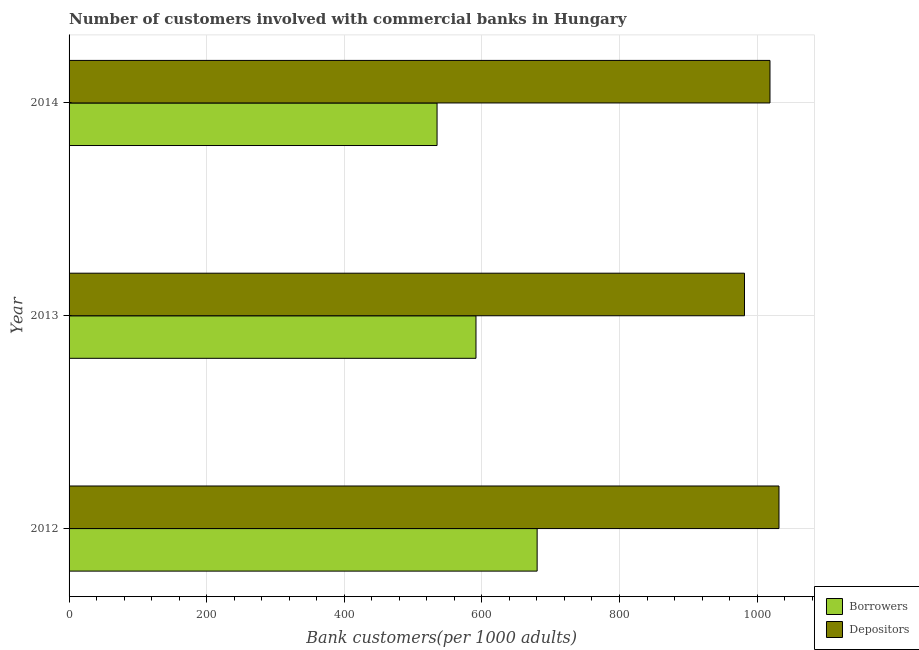How many different coloured bars are there?
Give a very brief answer. 2. How many groups of bars are there?
Your answer should be compact. 3. What is the label of the 3rd group of bars from the top?
Ensure brevity in your answer.  2012. What is the number of depositors in 2014?
Offer a terse response. 1018.74. Across all years, what is the maximum number of depositors?
Your answer should be very brief. 1031.82. Across all years, what is the minimum number of borrowers?
Make the answer very short. 534.85. What is the total number of borrowers in the graph?
Keep it short and to the point. 1806.59. What is the difference between the number of depositors in 2013 and that in 2014?
Ensure brevity in your answer.  -37.08. What is the difference between the number of borrowers in 2012 and the number of depositors in 2014?
Your answer should be very brief. -338.42. What is the average number of borrowers per year?
Your answer should be very brief. 602.2. In the year 2013, what is the difference between the number of borrowers and number of depositors?
Your answer should be compact. -390.25. What is the ratio of the number of borrowers in 2013 to that in 2014?
Your response must be concise. 1.11. Is the difference between the number of depositors in 2013 and 2014 greater than the difference between the number of borrowers in 2013 and 2014?
Your response must be concise. No. What is the difference between the highest and the second highest number of depositors?
Your answer should be very brief. 13.07. What is the difference between the highest and the lowest number of borrowers?
Your answer should be very brief. 145.46. In how many years, is the number of depositors greater than the average number of depositors taken over all years?
Your answer should be compact. 2. What does the 2nd bar from the top in 2013 represents?
Provide a succinct answer. Borrowers. What does the 1st bar from the bottom in 2014 represents?
Keep it short and to the point. Borrowers. How many bars are there?
Offer a terse response. 6. Are the values on the major ticks of X-axis written in scientific E-notation?
Give a very brief answer. No. Does the graph contain grids?
Make the answer very short. Yes. Where does the legend appear in the graph?
Your response must be concise. Bottom right. How are the legend labels stacked?
Offer a terse response. Vertical. What is the title of the graph?
Keep it short and to the point. Number of customers involved with commercial banks in Hungary. Does "Study and work" appear as one of the legend labels in the graph?
Your answer should be compact. No. What is the label or title of the X-axis?
Provide a short and direct response. Bank customers(per 1000 adults). What is the Bank customers(per 1000 adults) of Borrowers in 2012?
Make the answer very short. 680.32. What is the Bank customers(per 1000 adults) of Depositors in 2012?
Offer a terse response. 1031.82. What is the Bank customers(per 1000 adults) in Borrowers in 2013?
Make the answer very short. 591.42. What is the Bank customers(per 1000 adults) of Depositors in 2013?
Your response must be concise. 981.67. What is the Bank customers(per 1000 adults) in Borrowers in 2014?
Ensure brevity in your answer.  534.85. What is the Bank customers(per 1000 adults) in Depositors in 2014?
Your response must be concise. 1018.74. Across all years, what is the maximum Bank customers(per 1000 adults) in Borrowers?
Your answer should be very brief. 680.32. Across all years, what is the maximum Bank customers(per 1000 adults) of Depositors?
Keep it short and to the point. 1031.82. Across all years, what is the minimum Bank customers(per 1000 adults) of Borrowers?
Offer a terse response. 534.85. Across all years, what is the minimum Bank customers(per 1000 adults) of Depositors?
Keep it short and to the point. 981.67. What is the total Bank customers(per 1000 adults) in Borrowers in the graph?
Offer a terse response. 1806.59. What is the total Bank customers(per 1000 adults) in Depositors in the graph?
Your answer should be compact. 3032.23. What is the difference between the Bank customers(per 1000 adults) in Borrowers in 2012 and that in 2013?
Provide a short and direct response. 88.9. What is the difference between the Bank customers(per 1000 adults) in Depositors in 2012 and that in 2013?
Make the answer very short. 50.15. What is the difference between the Bank customers(per 1000 adults) in Borrowers in 2012 and that in 2014?
Keep it short and to the point. 145.46. What is the difference between the Bank customers(per 1000 adults) in Depositors in 2012 and that in 2014?
Provide a succinct answer. 13.07. What is the difference between the Bank customers(per 1000 adults) in Borrowers in 2013 and that in 2014?
Give a very brief answer. 56.56. What is the difference between the Bank customers(per 1000 adults) in Depositors in 2013 and that in 2014?
Make the answer very short. -37.07. What is the difference between the Bank customers(per 1000 adults) of Borrowers in 2012 and the Bank customers(per 1000 adults) of Depositors in 2013?
Keep it short and to the point. -301.35. What is the difference between the Bank customers(per 1000 adults) in Borrowers in 2012 and the Bank customers(per 1000 adults) in Depositors in 2014?
Make the answer very short. -338.42. What is the difference between the Bank customers(per 1000 adults) in Borrowers in 2013 and the Bank customers(per 1000 adults) in Depositors in 2014?
Ensure brevity in your answer.  -427.33. What is the average Bank customers(per 1000 adults) of Borrowers per year?
Offer a terse response. 602.2. What is the average Bank customers(per 1000 adults) of Depositors per year?
Your answer should be compact. 1010.74. In the year 2012, what is the difference between the Bank customers(per 1000 adults) of Borrowers and Bank customers(per 1000 adults) of Depositors?
Provide a succinct answer. -351.5. In the year 2013, what is the difference between the Bank customers(per 1000 adults) in Borrowers and Bank customers(per 1000 adults) in Depositors?
Your response must be concise. -390.25. In the year 2014, what is the difference between the Bank customers(per 1000 adults) in Borrowers and Bank customers(per 1000 adults) in Depositors?
Offer a terse response. -483.89. What is the ratio of the Bank customers(per 1000 adults) of Borrowers in 2012 to that in 2013?
Offer a very short reply. 1.15. What is the ratio of the Bank customers(per 1000 adults) in Depositors in 2012 to that in 2013?
Provide a short and direct response. 1.05. What is the ratio of the Bank customers(per 1000 adults) of Borrowers in 2012 to that in 2014?
Provide a short and direct response. 1.27. What is the ratio of the Bank customers(per 1000 adults) of Depositors in 2012 to that in 2014?
Keep it short and to the point. 1.01. What is the ratio of the Bank customers(per 1000 adults) in Borrowers in 2013 to that in 2014?
Make the answer very short. 1.11. What is the ratio of the Bank customers(per 1000 adults) of Depositors in 2013 to that in 2014?
Keep it short and to the point. 0.96. What is the difference between the highest and the second highest Bank customers(per 1000 adults) in Borrowers?
Your response must be concise. 88.9. What is the difference between the highest and the second highest Bank customers(per 1000 adults) of Depositors?
Make the answer very short. 13.07. What is the difference between the highest and the lowest Bank customers(per 1000 adults) in Borrowers?
Offer a very short reply. 145.46. What is the difference between the highest and the lowest Bank customers(per 1000 adults) in Depositors?
Give a very brief answer. 50.15. 